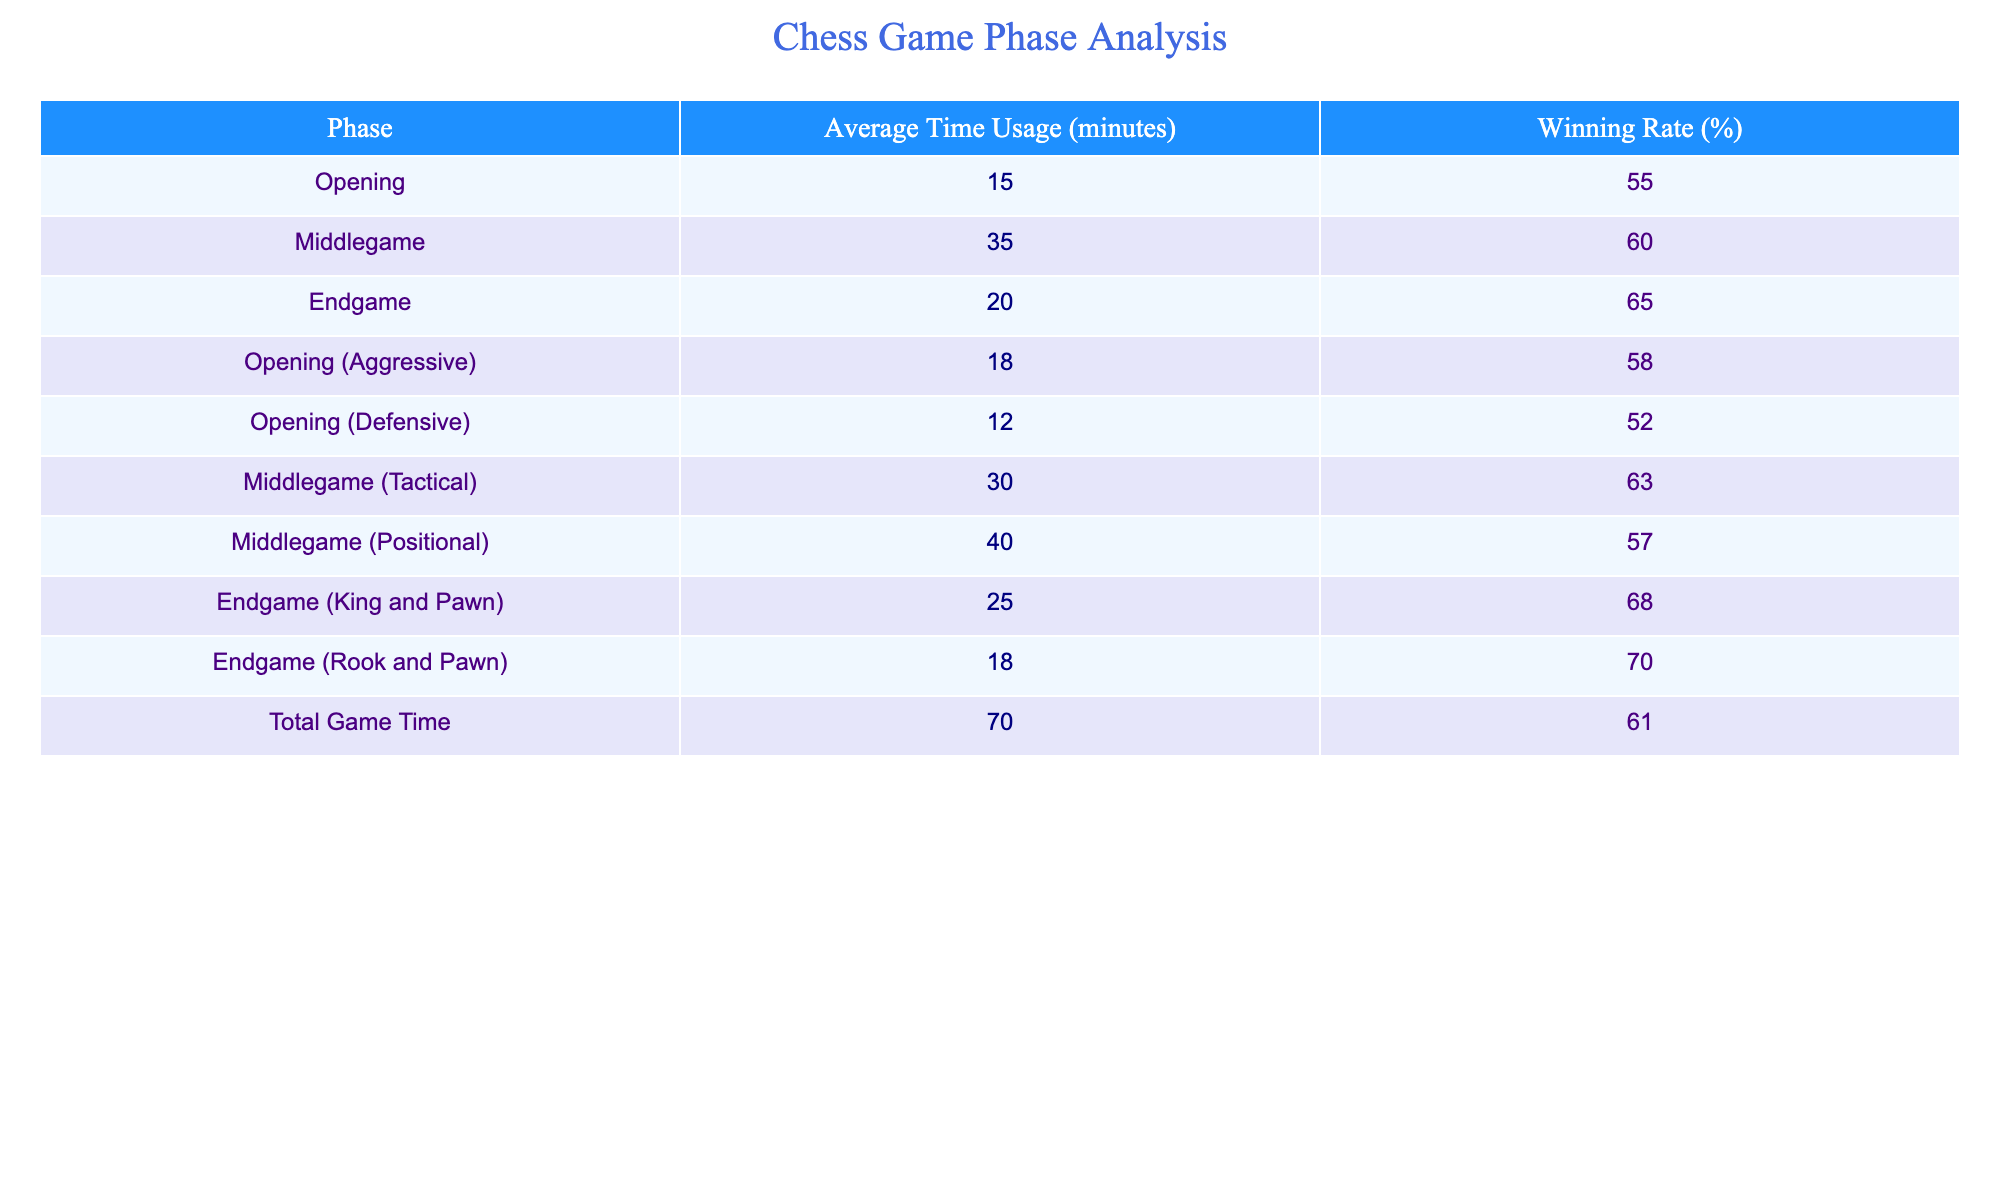What is the average time usage in the middlegame? The average time usage in the middlegame is listed in the table, where it states 35 minutes.
Answer: 35 minutes Which phase has the highest winning rate? Looking at the winning rates, the Rook and Pawn endgame has a winning rate of 70%, which is the highest among all listed phases.
Answer: Rook and Pawn endgame What is the average time usage for the endgame? The table states the average time usage for the endgame is 20 minutes.
Answer: 20 minutes Was the winning rate during the defensive opening higher than during the aggressive opening? The winning rate for the defensive opening is 52%, while the aggressive opening's rate is 58%. Therefore, the defensive opening's rate is not higher.
Answer: No What is the total average time usage in all game phases combined? To calculate this, we take the total game time from the table, which is 70 minutes; thus, no further calculation is needed.
Answer: 70 minutes If a player spends more time in the middlegame compared to the endgame, do they necessarily win more? The winning rates show that while the middlegame (60%) has a lower rate than the endgame (65%), we cannot definitively conclude that more time spent translates to a higher winning rate across different phases.
Answer: No What is the difference in winning rates between the Tactical and Positional middlegame? The Tactical middlegame has a winning rate of 63%, while the Positional middlegame has a rate of 57%. Therefore, the difference is 63% - 57% = 6%.
Answer: 6% Is the average time used in the Endgame (King and Pawn) higher than that in the Opening (Aggressive)? The average time for the Endgame (King and Pawn) is 25 minutes, while the Aggressive Opening uses 18 minutes. Thus, 25 minutes is greater than 18 minutes.
Answer: Yes What is the average winning rate of all game phases? To find the average winning rate, sum all winning rates (55 + 60 + 65 + 58 + 52 + 63 + 57 + 68 + 70 + 61) =  609 and divide by the number of phases (10), resulting in an average of 60.9%.
Answer: 60.9% 